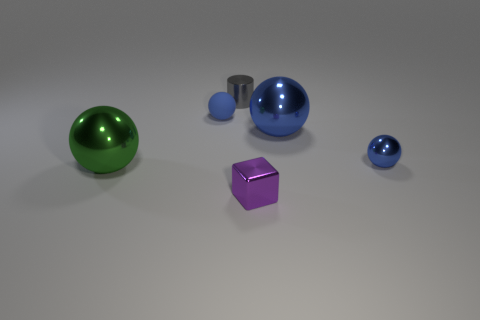Subtract all blue cylinders. How many blue spheres are left? 3 Add 4 gray cylinders. How many objects exist? 10 Subtract all blocks. How many objects are left? 5 Add 5 large green shiny spheres. How many large green shiny spheres are left? 6 Add 5 small red balls. How many small red balls exist? 5 Subtract 0 red cylinders. How many objects are left? 6 Subtract all large yellow metallic objects. Subtract all blocks. How many objects are left? 5 